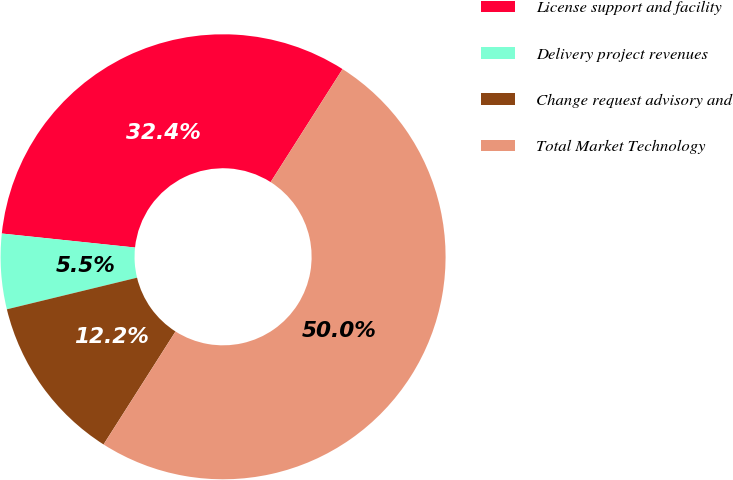<chart> <loc_0><loc_0><loc_500><loc_500><pie_chart><fcel>License support and facility<fcel>Delivery project revenues<fcel>Change request advisory and<fcel>Total Market Technology<nl><fcel>32.35%<fcel>5.46%<fcel>12.18%<fcel>50.0%<nl></chart> 